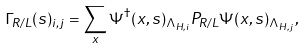<formula> <loc_0><loc_0><loc_500><loc_500>\Gamma _ { R / L } ( s ) _ { i , j } = \sum _ { x } \Psi ^ { \dagger } ( x , s ) _ { \Lambda _ { H , i } } P _ { R / L } \Psi ( x , s ) _ { \Lambda _ { H , j } } ,</formula> 